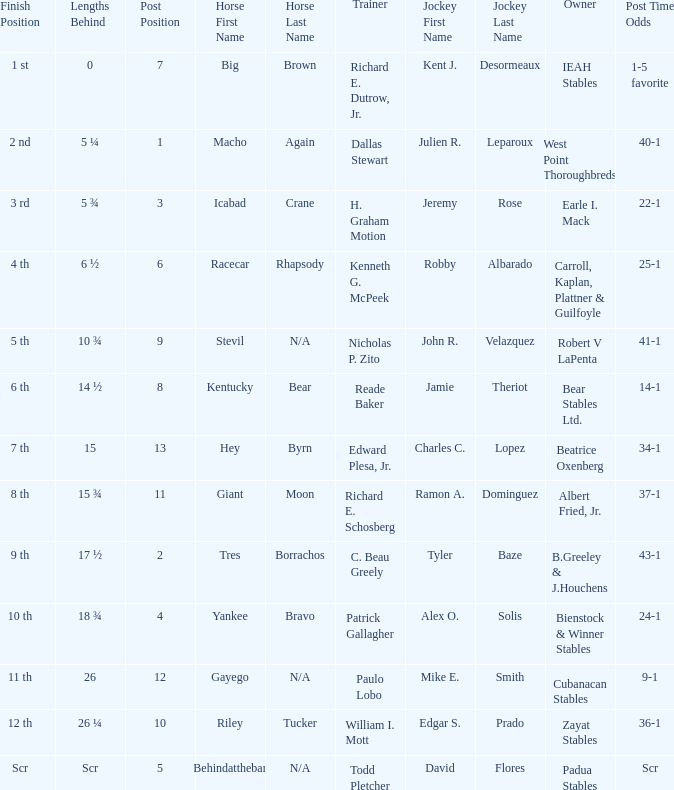Who was the jockey that had post time odds of 34-1? Charles C. Lopez. 